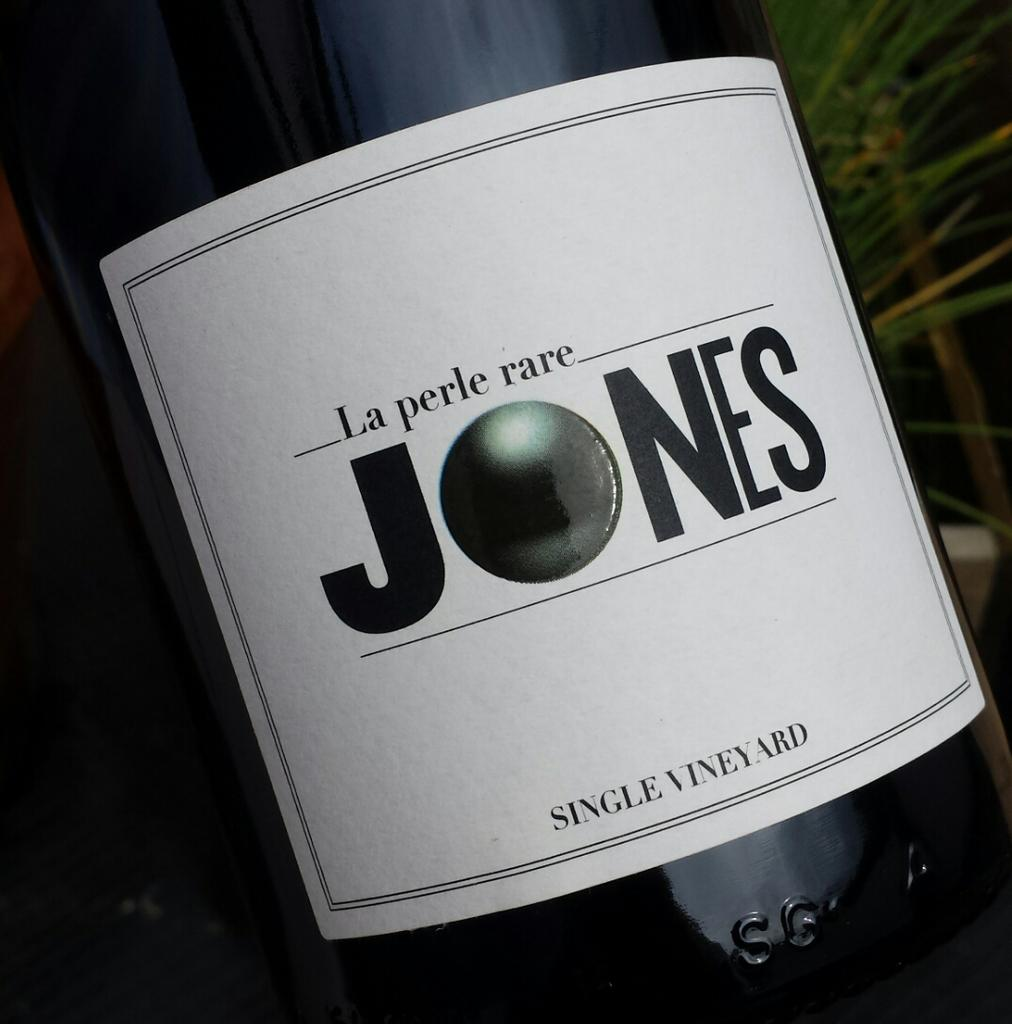What object is present in the image that can hold a liquid? There is a bottle in the image that can hold a liquid. What is attached to the bottle? A white color paper is attached to the bottle. What can be found on the paper? There is text on the paper. What type of natural elements can be seen in the image? A few leaves are visible in the top right corner of the image. What is the opinion of the grain in the image? There is no grain present in the image, so it is not possible to determine its opinion. 